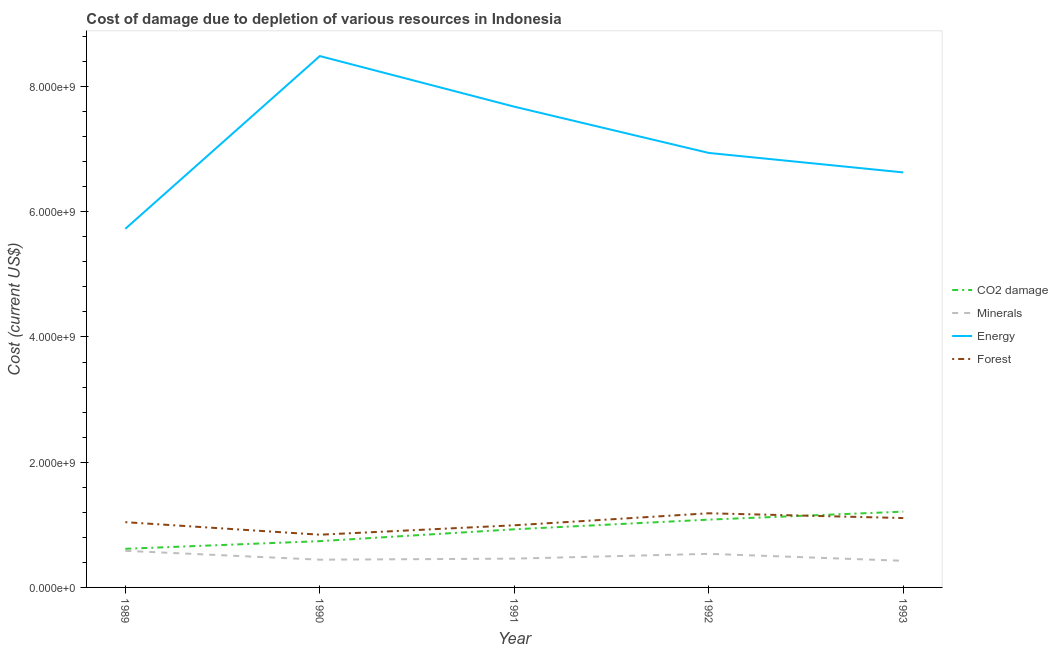Is the number of lines equal to the number of legend labels?
Give a very brief answer. Yes. What is the cost of damage due to depletion of minerals in 1993?
Offer a terse response. 4.25e+08. Across all years, what is the maximum cost of damage due to depletion of minerals?
Keep it short and to the point. 5.84e+08. Across all years, what is the minimum cost of damage due to depletion of coal?
Offer a terse response. 6.17e+08. What is the total cost of damage due to depletion of energy in the graph?
Your response must be concise. 3.55e+1. What is the difference between the cost of damage due to depletion of energy in 1991 and that in 1993?
Keep it short and to the point. 1.05e+09. What is the difference between the cost of damage due to depletion of energy in 1992 and the cost of damage due to depletion of forests in 1993?
Provide a succinct answer. 5.83e+09. What is the average cost of damage due to depletion of energy per year?
Offer a very short reply. 7.09e+09. In the year 1989, what is the difference between the cost of damage due to depletion of coal and cost of damage due to depletion of forests?
Make the answer very short. -4.25e+08. What is the ratio of the cost of damage due to depletion of energy in 1989 to that in 1993?
Give a very brief answer. 0.86. Is the difference between the cost of damage due to depletion of minerals in 1990 and 1992 greater than the difference between the cost of damage due to depletion of coal in 1990 and 1992?
Keep it short and to the point. Yes. What is the difference between the highest and the second highest cost of damage due to depletion of energy?
Your answer should be compact. 8.08e+08. What is the difference between the highest and the lowest cost of damage due to depletion of coal?
Your response must be concise. 5.94e+08. Is the sum of the cost of damage due to depletion of forests in 1990 and 1992 greater than the maximum cost of damage due to depletion of coal across all years?
Your response must be concise. Yes. Is it the case that in every year, the sum of the cost of damage due to depletion of coal and cost of damage due to depletion of minerals is greater than the cost of damage due to depletion of energy?
Your answer should be very brief. No. Does the cost of damage due to depletion of coal monotonically increase over the years?
Give a very brief answer. Yes. Is the cost of damage due to depletion of minerals strictly greater than the cost of damage due to depletion of forests over the years?
Keep it short and to the point. No. How many lines are there?
Provide a succinct answer. 4. How many years are there in the graph?
Offer a terse response. 5. Are the values on the major ticks of Y-axis written in scientific E-notation?
Your response must be concise. Yes. Does the graph contain any zero values?
Provide a succinct answer. No. How many legend labels are there?
Your answer should be very brief. 4. What is the title of the graph?
Make the answer very short. Cost of damage due to depletion of various resources in Indonesia . What is the label or title of the Y-axis?
Provide a short and direct response. Cost (current US$). What is the Cost (current US$) of CO2 damage in 1989?
Your response must be concise. 6.17e+08. What is the Cost (current US$) in Minerals in 1989?
Offer a terse response. 5.84e+08. What is the Cost (current US$) of Energy in 1989?
Your answer should be very brief. 5.73e+09. What is the Cost (current US$) of Forest in 1989?
Offer a terse response. 1.04e+09. What is the Cost (current US$) in CO2 damage in 1990?
Provide a succinct answer. 7.39e+08. What is the Cost (current US$) in Minerals in 1990?
Your answer should be compact. 4.43e+08. What is the Cost (current US$) of Energy in 1990?
Your answer should be compact. 8.49e+09. What is the Cost (current US$) in Forest in 1990?
Offer a terse response. 8.42e+08. What is the Cost (current US$) of CO2 damage in 1991?
Keep it short and to the point. 9.28e+08. What is the Cost (current US$) of Minerals in 1991?
Provide a succinct answer. 4.60e+08. What is the Cost (current US$) of Energy in 1991?
Offer a terse response. 7.68e+09. What is the Cost (current US$) in Forest in 1991?
Your answer should be very brief. 9.92e+08. What is the Cost (current US$) in CO2 damage in 1992?
Your response must be concise. 1.08e+09. What is the Cost (current US$) in Minerals in 1992?
Provide a short and direct response. 5.37e+08. What is the Cost (current US$) of Energy in 1992?
Provide a succinct answer. 6.94e+09. What is the Cost (current US$) of Forest in 1992?
Keep it short and to the point. 1.18e+09. What is the Cost (current US$) of CO2 damage in 1993?
Ensure brevity in your answer.  1.21e+09. What is the Cost (current US$) in Minerals in 1993?
Ensure brevity in your answer.  4.25e+08. What is the Cost (current US$) of Energy in 1993?
Provide a short and direct response. 6.63e+09. What is the Cost (current US$) of Forest in 1993?
Provide a succinct answer. 1.11e+09. Across all years, what is the maximum Cost (current US$) in CO2 damage?
Your response must be concise. 1.21e+09. Across all years, what is the maximum Cost (current US$) in Minerals?
Provide a short and direct response. 5.84e+08. Across all years, what is the maximum Cost (current US$) in Energy?
Your response must be concise. 8.49e+09. Across all years, what is the maximum Cost (current US$) of Forest?
Provide a short and direct response. 1.18e+09. Across all years, what is the minimum Cost (current US$) in CO2 damage?
Provide a short and direct response. 6.17e+08. Across all years, what is the minimum Cost (current US$) of Minerals?
Offer a very short reply. 4.25e+08. Across all years, what is the minimum Cost (current US$) in Energy?
Ensure brevity in your answer.  5.73e+09. Across all years, what is the minimum Cost (current US$) in Forest?
Ensure brevity in your answer.  8.42e+08. What is the total Cost (current US$) of CO2 damage in the graph?
Offer a terse response. 4.58e+09. What is the total Cost (current US$) of Minerals in the graph?
Your answer should be compact. 2.45e+09. What is the total Cost (current US$) of Energy in the graph?
Your answer should be compact. 3.55e+1. What is the total Cost (current US$) of Forest in the graph?
Your answer should be very brief. 5.17e+09. What is the difference between the Cost (current US$) in CO2 damage in 1989 and that in 1990?
Offer a very short reply. -1.22e+08. What is the difference between the Cost (current US$) in Minerals in 1989 and that in 1990?
Provide a succinct answer. 1.41e+08. What is the difference between the Cost (current US$) in Energy in 1989 and that in 1990?
Offer a terse response. -2.76e+09. What is the difference between the Cost (current US$) of Forest in 1989 and that in 1990?
Give a very brief answer. 2.00e+08. What is the difference between the Cost (current US$) in CO2 damage in 1989 and that in 1991?
Keep it short and to the point. -3.12e+08. What is the difference between the Cost (current US$) in Minerals in 1989 and that in 1991?
Ensure brevity in your answer.  1.25e+08. What is the difference between the Cost (current US$) of Energy in 1989 and that in 1991?
Your answer should be very brief. -1.95e+09. What is the difference between the Cost (current US$) in Forest in 1989 and that in 1991?
Make the answer very short. 4.99e+07. What is the difference between the Cost (current US$) in CO2 damage in 1989 and that in 1992?
Make the answer very short. -4.66e+08. What is the difference between the Cost (current US$) of Minerals in 1989 and that in 1992?
Make the answer very short. 4.78e+07. What is the difference between the Cost (current US$) in Energy in 1989 and that in 1992?
Offer a very short reply. -1.21e+09. What is the difference between the Cost (current US$) in Forest in 1989 and that in 1992?
Ensure brevity in your answer.  -1.42e+08. What is the difference between the Cost (current US$) of CO2 damage in 1989 and that in 1993?
Give a very brief answer. -5.94e+08. What is the difference between the Cost (current US$) of Minerals in 1989 and that in 1993?
Offer a terse response. 1.59e+08. What is the difference between the Cost (current US$) in Energy in 1989 and that in 1993?
Provide a succinct answer. -9.01e+08. What is the difference between the Cost (current US$) of Forest in 1989 and that in 1993?
Offer a very short reply. -6.57e+07. What is the difference between the Cost (current US$) in CO2 damage in 1990 and that in 1991?
Give a very brief answer. -1.89e+08. What is the difference between the Cost (current US$) in Minerals in 1990 and that in 1991?
Keep it short and to the point. -1.65e+07. What is the difference between the Cost (current US$) in Energy in 1990 and that in 1991?
Ensure brevity in your answer.  8.08e+08. What is the difference between the Cost (current US$) in Forest in 1990 and that in 1991?
Your answer should be compact. -1.50e+08. What is the difference between the Cost (current US$) in CO2 damage in 1990 and that in 1992?
Your response must be concise. -3.44e+08. What is the difference between the Cost (current US$) of Minerals in 1990 and that in 1992?
Provide a succinct answer. -9.35e+07. What is the difference between the Cost (current US$) of Energy in 1990 and that in 1992?
Ensure brevity in your answer.  1.55e+09. What is the difference between the Cost (current US$) in Forest in 1990 and that in 1992?
Offer a very short reply. -3.42e+08. What is the difference between the Cost (current US$) of CO2 damage in 1990 and that in 1993?
Offer a very short reply. -4.71e+08. What is the difference between the Cost (current US$) of Minerals in 1990 and that in 1993?
Make the answer very short. 1.79e+07. What is the difference between the Cost (current US$) of Energy in 1990 and that in 1993?
Provide a succinct answer. 1.86e+09. What is the difference between the Cost (current US$) in Forest in 1990 and that in 1993?
Offer a terse response. -2.66e+08. What is the difference between the Cost (current US$) in CO2 damage in 1991 and that in 1992?
Provide a short and direct response. -1.54e+08. What is the difference between the Cost (current US$) of Minerals in 1991 and that in 1992?
Your answer should be very brief. -7.69e+07. What is the difference between the Cost (current US$) in Energy in 1991 and that in 1992?
Your answer should be compact. 7.39e+08. What is the difference between the Cost (current US$) in Forest in 1991 and that in 1992?
Your answer should be compact. -1.92e+08. What is the difference between the Cost (current US$) in CO2 damage in 1991 and that in 1993?
Your answer should be compact. -2.82e+08. What is the difference between the Cost (current US$) in Minerals in 1991 and that in 1993?
Provide a succinct answer. 3.44e+07. What is the difference between the Cost (current US$) of Energy in 1991 and that in 1993?
Your answer should be compact. 1.05e+09. What is the difference between the Cost (current US$) in Forest in 1991 and that in 1993?
Provide a succinct answer. -1.16e+08. What is the difference between the Cost (current US$) of CO2 damage in 1992 and that in 1993?
Your response must be concise. -1.28e+08. What is the difference between the Cost (current US$) of Minerals in 1992 and that in 1993?
Offer a terse response. 1.11e+08. What is the difference between the Cost (current US$) in Energy in 1992 and that in 1993?
Your response must be concise. 3.11e+08. What is the difference between the Cost (current US$) in Forest in 1992 and that in 1993?
Offer a very short reply. 7.63e+07. What is the difference between the Cost (current US$) of CO2 damage in 1989 and the Cost (current US$) of Minerals in 1990?
Your answer should be very brief. 1.74e+08. What is the difference between the Cost (current US$) of CO2 damage in 1989 and the Cost (current US$) of Energy in 1990?
Your response must be concise. -7.87e+09. What is the difference between the Cost (current US$) in CO2 damage in 1989 and the Cost (current US$) in Forest in 1990?
Make the answer very short. -2.25e+08. What is the difference between the Cost (current US$) in Minerals in 1989 and the Cost (current US$) in Energy in 1990?
Keep it short and to the point. -7.90e+09. What is the difference between the Cost (current US$) of Minerals in 1989 and the Cost (current US$) of Forest in 1990?
Give a very brief answer. -2.58e+08. What is the difference between the Cost (current US$) in Energy in 1989 and the Cost (current US$) in Forest in 1990?
Provide a succinct answer. 4.89e+09. What is the difference between the Cost (current US$) of CO2 damage in 1989 and the Cost (current US$) of Minerals in 1991?
Make the answer very short. 1.57e+08. What is the difference between the Cost (current US$) of CO2 damage in 1989 and the Cost (current US$) of Energy in 1991?
Your response must be concise. -7.06e+09. What is the difference between the Cost (current US$) of CO2 damage in 1989 and the Cost (current US$) of Forest in 1991?
Provide a succinct answer. -3.76e+08. What is the difference between the Cost (current US$) in Minerals in 1989 and the Cost (current US$) in Energy in 1991?
Give a very brief answer. -7.09e+09. What is the difference between the Cost (current US$) in Minerals in 1989 and the Cost (current US$) in Forest in 1991?
Your response must be concise. -4.08e+08. What is the difference between the Cost (current US$) in Energy in 1989 and the Cost (current US$) in Forest in 1991?
Provide a short and direct response. 4.74e+09. What is the difference between the Cost (current US$) of CO2 damage in 1989 and the Cost (current US$) of Minerals in 1992?
Provide a succinct answer. 8.02e+07. What is the difference between the Cost (current US$) of CO2 damage in 1989 and the Cost (current US$) of Energy in 1992?
Your answer should be compact. -6.32e+09. What is the difference between the Cost (current US$) of CO2 damage in 1989 and the Cost (current US$) of Forest in 1992?
Provide a short and direct response. -5.67e+08. What is the difference between the Cost (current US$) of Minerals in 1989 and the Cost (current US$) of Energy in 1992?
Offer a terse response. -6.35e+09. What is the difference between the Cost (current US$) in Minerals in 1989 and the Cost (current US$) in Forest in 1992?
Offer a very short reply. -6.00e+08. What is the difference between the Cost (current US$) of Energy in 1989 and the Cost (current US$) of Forest in 1992?
Your response must be concise. 4.54e+09. What is the difference between the Cost (current US$) of CO2 damage in 1989 and the Cost (current US$) of Minerals in 1993?
Make the answer very short. 1.92e+08. What is the difference between the Cost (current US$) in CO2 damage in 1989 and the Cost (current US$) in Energy in 1993?
Give a very brief answer. -6.01e+09. What is the difference between the Cost (current US$) in CO2 damage in 1989 and the Cost (current US$) in Forest in 1993?
Offer a very short reply. -4.91e+08. What is the difference between the Cost (current US$) in Minerals in 1989 and the Cost (current US$) in Energy in 1993?
Your response must be concise. -6.04e+09. What is the difference between the Cost (current US$) of Minerals in 1989 and the Cost (current US$) of Forest in 1993?
Make the answer very short. -5.23e+08. What is the difference between the Cost (current US$) of Energy in 1989 and the Cost (current US$) of Forest in 1993?
Make the answer very short. 4.62e+09. What is the difference between the Cost (current US$) of CO2 damage in 1990 and the Cost (current US$) of Minerals in 1991?
Offer a terse response. 2.79e+08. What is the difference between the Cost (current US$) of CO2 damage in 1990 and the Cost (current US$) of Energy in 1991?
Your answer should be very brief. -6.94e+09. What is the difference between the Cost (current US$) in CO2 damage in 1990 and the Cost (current US$) in Forest in 1991?
Make the answer very short. -2.53e+08. What is the difference between the Cost (current US$) of Minerals in 1990 and the Cost (current US$) of Energy in 1991?
Offer a very short reply. -7.24e+09. What is the difference between the Cost (current US$) in Minerals in 1990 and the Cost (current US$) in Forest in 1991?
Give a very brief answer. -5.49e+08. What is the difference between the Cost (current US$) of Energy in 1990 and the Cost (current US$) of Forest in 1991?
Offer a terse response. 7.49e+09. What is the difference between the Cost (current US$) in CO2 damage in 1990 and the Cost (current US$) in Minerals in 1992?
Your response must be concise. 2.02e+08. What is the difference between the Cost (current US$) of CO2 damage in 1990 and the Cost (current US$) of Energy in 1992?
Offer a terse response. -6.20e+09. What is the difference between the Cost (current US$) in CO2 damage in 1990 and the Cost (current US$) in Forest in 1992?
Keep it short and to the point. -4.45e+08. What is the difference between the Cost (current US$) of Minerals in 1990 and the Cost (current US$) of Energy in 1992?
Make the answer very short. -6.50e+09. What is the difference between the Cost (current US$) of Minerals in 1990 and the Cost (current US$) of Forest in 1992?
Your answer should be compact. -7.41e+08. What is the difference between the Cost (current US$) of Energy in 1990 and the Cost (current US$) of Forest in 1992?
Your answer should be very brief. 7.30e+09. What is the difference between the Cost (current US$) of CO2 damage in 1990 and the Cost (current US$) of Minerals in 1993?
Offer a very short reply. 3.14e+08. What is the difference between the Cost (current US$) in CO2 damage in 1990 and the Cost (current US$) in Energy in 1993?
Your answer should be compact. -5.89e+09. What is the difference between the Cost (current US$) in CO2 damage in 1990 and the Cost (current US$) in Forest in 1993?
Ensure brevity in your answer.  -3.69e+08. What is the difference between the Cost (current US$) of Minerals in 1990 and the Cost (current US$) of Energy in 1993?
Offer a terse response. -6.19e+09. What is the difference between the Cost (current US$) in Minerals in 1990 and the Cost (current US$) in Forest in 1993?
Your answer should be very brief. -6.65e+08. What is the difference between the Cost (current US$) of Energy in 1990 and the Cost (current US$) of Forest in 1993?
Provide a short and direct response. 7.38e+09. What is the difference between the Cost (current US$) of CO2 damage in 1991 and the Cost (current US$) of Minerals in 1992?
Offer a terse response. 3.92e+08. What is the difference between the Cost (current US$) in CO2 damage in 1991 and the Cost (current US$) in Energy in 1992?
Offer a very short reply. -6.01e+09. What is the difference between the Cost (current US$) of CO2 damage in 1991 and the Cost (current US$) of Forest in 1992?
Your response must be concise. -2.56e+08. What is the difference between the Cost (current US$) of Minerals in 1991 and the Cost (current US$) of Energy in 1992?
Your answer should be compact. -6.48e+09. What is the difference between the Cost (current US$) in Minerals in 1991 and the Cost (current US$) in Forest in 1992?
Your answer should be compact. -7.25e+08. What is the difference between the Cost (current US$) in Energy in 1991 and the Cost (current US$) in Forest in 1992?
Offer a terse response. 6.49e+09. What is the difference between the Cost (current US$) of CO2 damage in 1991 and the Cost (current US$) of Minerals in 1993?
Provide a short and direct response. 5.03e+08. What is the difference between the Cost (current US$) in CO2 damage in 1991 and the Cost (current US$) in Energy in 1993?
Your answer should be very brief. -5.70e+09. What is the difference between the Cost (current US$) of CO2 damage in 1991 and the Cost (current US$) of Forest in 1993?
Make the answer very short. -1.79e+08. What is the difference between the Cost (current US$) in Minerals in 1991 and the Cost (current US$) in Energy in 1993?
Offer a terse response. -6.17e+09. What is the difference between the Cost (current US$) of Minerals in 1991 and the Cost (current US$) of Forest in 1993?
Your answer should be compact. -6.48e+08. What is the difference between the Cost (current US$) of Energy in 1991 and the Cost (current US$) of Forest in 1993?
Your response must be concise. 6.57e+09. What is the difference between the Cost (current US$) in CO2 damage in 1992 and the Cost (current US$) in Minerals in 1993?
Your answer should be very brief. 6.58e+08. What is the difference between the Cost (current US$) in CO2 damage in 1992 and the Cost (current US$) in Energy in 1993?
Make the answer very short. -5.55e+09. What is the difference between the Cost (current US$) of CO2 damage in 1992 and the Cost (current US$) of Forest in 1993?
Give a very brief answer. -2.50e+07. What is the difference between the Cost (current US$) in Minerals in 1992 and the Cost (current US$) in Energy in 1993?
Your response must be concise. -6.09e+09. What is the difference between the Cost (current US$) of Minerals in 1992 and the Cost (current US$) of Forest in 1993?
Provide a succinct answer. -5.71e+08. What is the difference between the Cost (current US$) of Energy in 1992 and the Cost (current US$) of Forest in 1993?
Provide a short and direct response. 5.83e+09. What is the average Cost (current US$) of CO2 damage per year?
Keep it short and to the point. 9.16e+08. What is the average Cost (current US$) of Minerals per year?
Offer a very short reply. 4.90e+08. What is the average Cost (current US$) of Energy per year?
Give a very brief answer. 7.09e+09. What is the average Cost (current US$) of Forest per year?
Offer a very short reply. 1.03e+09. In the year 1989, what is the difference between the Cost (current US$) in CO2 damage and Cost (current US$) in Minerals?
Your answer should be very brief. 3.24e+07. In the year 1989, what is the difference between the Cost (current US$) of CO2 damage and Cost (current US$) of Energy?
Offer a very short reply. -5.11e+09. In the year 1989, what is the difference between the Cost (current US$) of CO2 damage and Cost (current US$) of Forest?
Keep it short and to the point. -4.25e+08. In the year 1989, what is the difference between the Cost (current US$) of Minerals and Cost (current US$) of Energy?
Offer a very short reply. -5.14e+09. In the year 1989, what is the difference between the Cost (current US$) in Minerals and Cost (current US$) in Forest?
Your answer should be very brief. -4.58e+08. In the year 1989, what is the difference between the Cost (current US$) in Energy and Cost (current US$) in Forest?
Your answer should be compact. 4.69e+09. In the year 1990, what is the difference between the Cost (current US$) of CO2 damage and Cost (current US$) of Minerals?
Your answer should be very brief. 2.96e+08. In the year 1990, what is the difference between the Cost (current US$) of CO2 damage and Cost (current US$) of Energy?
Make the answer very short. -7.75e+09. In the year 1990, what is the difference between the Cost (current US$) of CO2 damage and Cost (current US$) of Forest?
Your answer should be very brief. -1.03e+08. In the year 1990, what is the difference between the Cost (current US$) in Minerals and Cost (current US$) in Energy?
Give a very brief answer. -8.04e+09. In the year 1990, what is the difference between the Cost (current US$) in Minerals and Cost (current US$) in Forest?
Provide a short and direct response. -3.99e+08. In the year 1990, what is the difference between the Cost (current US$) of Energy and Cost (current US$) of Forest?
Make the answer very short. 7.64e+09. In the year 1991, what is the difference between the Cost (current US$) in CO2 damage and Cost (current US$) in Minerals?
Provide a succinct answer. 4.69e+08. In the year 1991, what is the difference between the Cost (current US$) in CO2 damage and Cost (current US$) in Energy?
Provide a succinct answer. -6.75e+09. In the year 1991, what is the difference between the Cost (current US$) in CO2 damage and Cost (current US$) in Forest?
Your answer should be very brief. -6.39e+07. In the year 1991, what is the difference between the Cost (current US$) in Minerals and Cost (current US$) in Energy?
Offer a terse response. -7.22e+09. In the year 1991, what is the difference between the Cost (current US$) in Minerals and Cost (current US$) in Forest?
Make the answer very short. -5.33e+08. In the year 1991, what is the difference between the Cost (current US$) of Energy and Cost (current US$) of Forest?
Ensure brevity in your answer.  6.69e+09. In the year 1992, what is the difference between the Cost (current US$) in CO2 damage and Cost (current US$) in Minerals?
Your response must be concise. 5.46e+08. In the year 1992, what is the difference between the Cost (current US$) of CO2 damage and Cost (current US$) of Energy?
Your answer should be compact. -5.86e+09. In the year 1992, what is the difference between the Cost (current US$) of CO2 damage and Cost (current US$) of Forest?
Ensure brevity in your answer.  -1.01e+08. In the year 1992, what is the difference between the Cost (current US$) in Minerals and Cost (current US$) in Energy?
Keep it short and to the point. -6.40e+09. In the year 1992, what is the difference between the Cost (current US$) in Minerals and Cost (current US$) in Forest?
Provide a succinct answer. -6.48e+08. In the year 1992, what is the difference between the Cost (current US$) of Energy and Cost (current US$) of Forest?
Keep it short and to the point. 5.76e+09. In the year 1993, what is the difference between the Cost (current US$) in CO2 damage and Cost (current US$) in Minerals?
Offer a very short reply. 7.85e+08. In the year 1993, what is the difference between the Cost (current US$) in CO2 damage and Cost (current US$) in Energy?
Offer a very short reply. -5.42e+09. In the year 1993, what is the difference between the Cost (current US$) of CO2 damage and Cost (current US$) of Forest?
Ensure brevity in your answer.  1.03e+08. In the year 1993, what is the difference between the Cost (current US$) in Minerals and Cost (current US$) in Energy?
Ensure brevity in your answer.  -6.20e+09. In the year 1993, what is the difference between the Cost (current US$) of Minerals and Cost (current US$) of Forest?
Your answer should be very brief. -6.83e+08. In the year 1993, what is the difference between the Cost (current US$) in Energy and Cost (current US$) in Forest?
Make the answer very short. 5.52e+09. What is the ratio of the Cost (current US$) of CO2 damage in 1989 to that in 1990?
Give a very brief answer. 0.83. What is the ratio of the Cost (current US$) of Minerals in 1989 to that in 1990?
Give a very brief answer. 1.32. What is the ratio of the Cost (current US$) of Energy in 1989 to that in 1990?
Offer a terse response. 0.67. What is the ratio of the Cost (current US$) of Forest in 1989 to that in 1990?
Give a very brief answer. 1.24. What is the ratio of the Cost (current US$) of CO2 damage in 1989 to that in 1991?
Make the answer very short. 0.66. What is the ratio of the Cost (current US$) in Minerals in 1989 to that in 1991?
Give a very brief answer. 1.27. What is the ratio of the Cost (current US$) in Energy in 1989 to that in 1991?
Provide a succinct answer. 0.75. What is the ratio of the Cost (current US$) in Forest in 1989 to that in 1991?
Offer a very short reply. 1.05. What is the ratio of the Cost (current US$) in CO2 damage in 1989 to that in 1992?
Your answer should be very brief. 0.57. What is the ratio of the Cost (current US$) of Minerals in 1989 to that in 1992?
Give a very brief answer. 1.09. What is the ratio of the Cost (current US$) in Energy in 1989 to that in 1992?
Make the answer very short. 0.83. What is the ratio of the Cost (current US$) in Forest in 1989 to that in 1992?
Keep it short and to the point. 0.88. What is the ratio of the Cost (current US$) of CO2 damage in 1989 to that in 1993?
Offer a very short reply. 0.51. What is the ratio of the Cost (current US$) in Minerals in 1989 to that in 1993?
Make the answer very short. 1.37. What is the ratio of the Cost (current US$) in Energy in 1989 to that in 1993?
Provide a short and direct response. 0.86. What is the ratio of the Cost (current US$) in Forest in 1989 to that in 1993?
Your answer should be very brief. 0.94. What is the ratio of the Cost (current US$) in CO2 damage in 1990 to that in 1991?
Make the answer very short. 0.8. What is the ratio of the Cost (current US$) in Minerals in 1990 to that in 1991?
Offer a very short reply. 0.96. What is the ratio of the Cost (current US$) of Energy in 1990 to that in 1991?
Offer a very short reply. 1.11. What is the ratio of the Cost (current US$) in Forest in 1990 to that in 1991?
Make the answer very short. 0.85. What is the ratio of the Cost (current US$) of CO2 damage in 1990 to that in 1992?
Offer a very short reply. 0.68. What is the ratio of the Cost (current US$) in Minerals in 1990 to that in 1992?
Provide a short and direct response. 0.83. What is the ratio of the Cost (current US$) in Energy in 1990 to that in 1992?
Ensure brevity in your answer.  1.22. What is the ratio of the Cost (current US$) in Forest in 1990 to that in 1992?
Offer a very short reply. 0.71. What is the ratio of the Cost (current US$) of CO2 damage in 1990 to that in 1993?
Your response must be concise. 0.61. What is the ratio of the Cost (current US$) of Minerals in 1990 to that in 1993?
Ensure brevity in your answer.  1.04. What is the ratio of the Cost (current US$) in Energy in 1990 to that in 1993?
Your answer should be very brief. 1.28. What is the ratio of the Cost (current US$) in Forest in 1990 to that in 1993?
Make the answer very short. 0.76. What is the ratio of the Cost (current US$) in CO2 damage in 1991 to that in 1992?
Your answer should be compact. 0.86. What is the ratio of the Cost (current US$) of Minerals in 1991 to that in 1992?
Offer a terse response. 0.86. What is the ratio of the Cost (current US$) in Energy in 1991 to that in 1992?
Keep it short and to the point. 1.11. What is the ratio of the Cost (current US$) in Forest in 1991 to that in 1992?
Give a very brief answer. 0.84. What is the ratio of the Cost (current US$) of CO2 damage in 1991 to that in 1993?
Keep it short and to the point. 0.77. What is the ratio of the Cost (current US$) in Minerals in 1991 to that in 1993?
Provide a succinct answer. 1.08. What is the ratio of the Cost (current US$) in Energy in 1991 to that in 1993?
Provide a succinct answer. 1.16. What is the ratio of the Cost (current US$) of Forest in 1991 to that in 1993?
Your answer should be very brief. 0.9. What is the ratio of the Cost (current US$) of CO2 damage in 1992 to that in 1993?
Ensure brevity in your answer.  0.89. What is the ratio of the Cost (current US$) of Minerals in 1992 to that in 1993?
Give a very brief answer. 1.26. What is the ratio of the Cost (current US$) in Energy in 1992 to that in 1993?
Offer a terse response. 1.05. What is the ratio of the Cost (current US$) of Forest in 1992 to that in 1993?
Offer a terse response. 1.07. What is the difference between the highest and the second highest Cost (current US$) in CO2 damage?
Provide a succinct answer. 1.28e+08. What is the difference between the highest and the second highest Cost (current US$) in Minerals?
Your answer should be compact. 4.78e+07. What is the difference between the highest and the second highest Cost (current US$) in Energy?
Offer a terse response. 8.08e+08. What is the difference between the highest and the second highest Cost (current US$) of Forest?
Your answer should be compact. 7.63e+07. What is the difference between the highest and the lowest Cost (current US$) in CO2 damage?
Your response must be concise. 5.94e+08. What is the difference between the highest and the lowest Cost (current US$) of Minerals?
Give a very brief answer. 1.59e+08. What is the difference between the highest and the lowest Cost (current US$) of Energy?
Your response must be concise. 2.76e+09. What is the difference between the highest and the lowest Cost (current US$) in Forest?
Your answer should be very brief. 3.42e+08. 